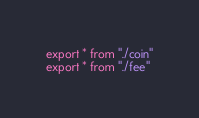Convert code to text. <code><loc_0><loc_0><loc_500><loc_500><_TypeScript_>export * from "./coin"
export * from "./fee"
</code> 